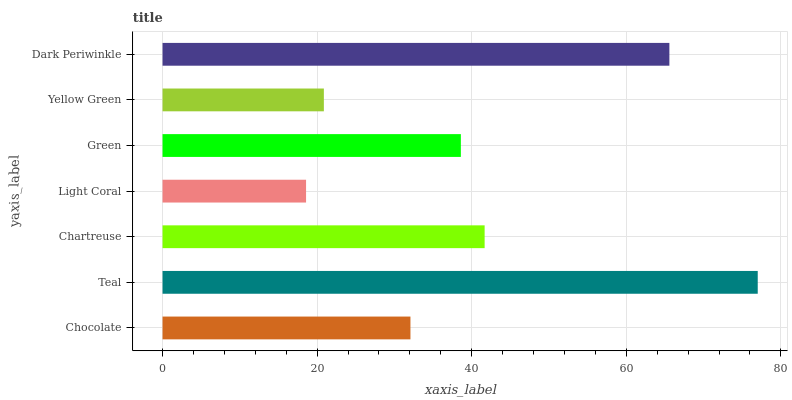Is Light Coral the minimum?
Answer yes or no. Yes. Is Teal the maximum?
Answer yes or no. Yes. Is Chartreuse the minimum?
Answer yes or no. No. Is Chartreuse the maximum?
Answer yes or no. No. Is Teal greater than Chartreuse?
Answer yes or no. Yes. Is Chartreuse less than Teal?
Answer yes or no. Yes. Is Chartreuse greater than Teal?
Answer yes or no. No. Is Teal less than Chartreuse?
Answer yes or no. No. Is Green the high median?
Answer yes or no. Yes. Is Green the low median?
Answer yes or no. Yes. Is Chartreuse the high median?
Answer yes or no. No. Is Chartreuse the low median?
Answer yes or no. No. 